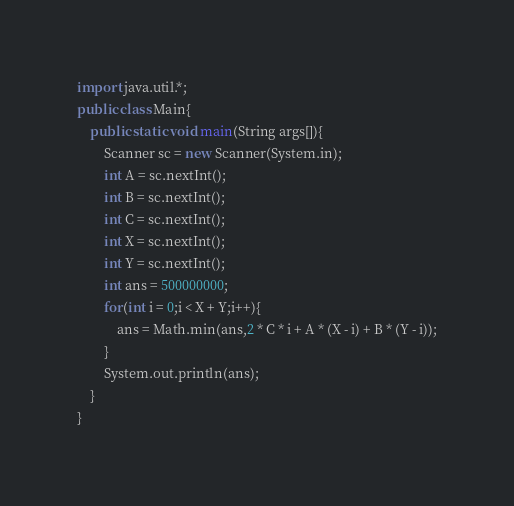Convert code to text. <code><loc_0><loc_0><loc_500><loc_500><_Java_>import java.util.*;
public class Main{
	public static void main(String args[]){
		Scanner sc = new Scanner(System.in);
		int A = sc.nextInt();
		int B = sc.nextInt();
		int C = sc.nextInt();
		int X = sc.nextInt();
		int Y = sc.nextInt();
		int ans = 500000000;
		for(int i = 0;i < X + Y;i++){
			ans = Math.min(ans,2 * C * i + A * (X - i) + B * (Y - i));
		}
		System.out.println(ans);
	}
}</code> 